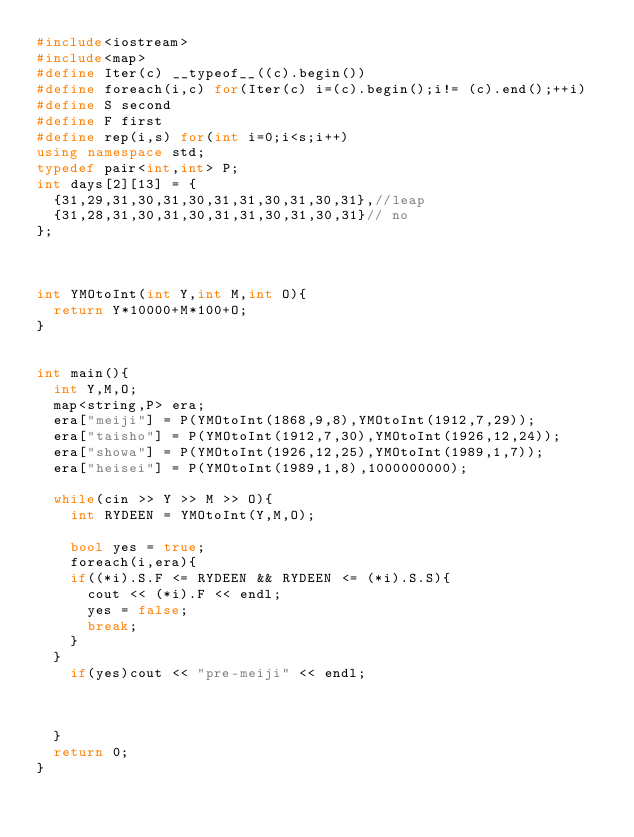Convert code to text. <code><loc_0><loc_0><loc_500><loc_500><_C++_>#include<iostream>
#include<map>
#define Iter(c) __typeof__((c).begin())
#define foreach(i,c) for(Iter(c) i=(c).begin();i!= (c).end();++i)
#define S second
#define F first
#define rep(i,s) for(int i=0;i<s;i++)
using namespace std;
typedef pair<int,int> P;
int days[2][13] = {
  {31,29,31,30,31,30,31,31,30,31,30,31},//leap
  {31,28,31,30,31,30,31,31,30,31,30,31}// no
};



int YMOtoInt(int Y,int M,int O){
  return Y*10000+M*100+O;
}


int main(){
  int Y,M,O;
  map<string,P> era; 
  era["meiji"] = P(YMOtoInt(1868,9,8),YMOtoInt(1912,7,29));
  era["taisho"] = P(YMOtoInt(1912,7,30),YMOtoInt(1926,12,24));
  era["showa"] = P(YMOtoInt(1926,12,25),YMOtoInt(1989,1,7));
  era["heisei"] = P(YMOtoInt(1989,1,8),1000000000);

  while(cin >> Y >> M >> O){
    int RYDEEN = YMOtoInt(Y,M,O);
 
    bool yes = true;
    foreach(i,era){     
    if((*i).S.F <= RYDEEN && RYDEEN <= (*i).S.S){
      cout << (*i).F << endl;
      yes = false;
      break;
    }
  }
    if(yes)cout << "pre-meiji" << endl;
    


  }
  return 0;
}</code> 